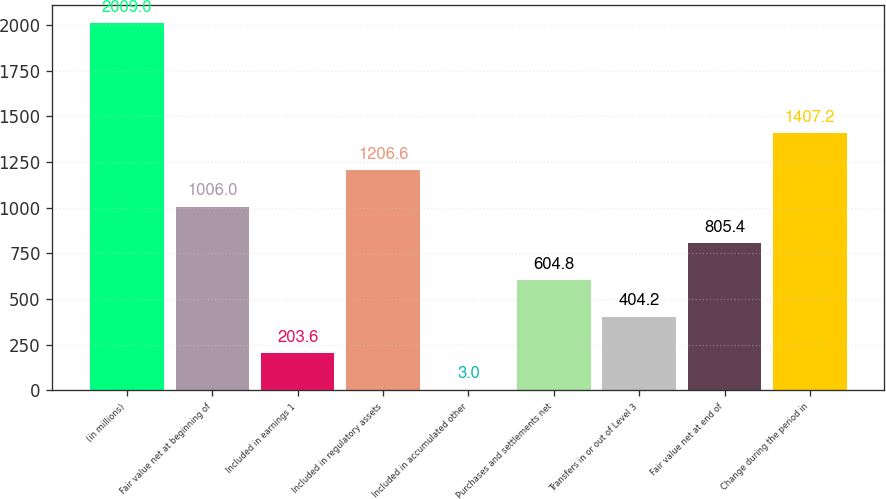Convert chart. <chart><loc_0><loc_0><loc_500><loc_500><bar_chart><fcel>(in millions)<fcel>Fair value net at beginning of<fcel>Included in earnings 1<fcel>Included in regulatory assets<fcel>Included in accumulated other<fcel>Purchases and settlements net<fcel>Transfers in or out of Level 3<fcel>Fair value net at end of<fcel>Change during the period in<nl><fcel>2009<fcel>1006<fcel>203.6<fcel>1206.6<fcel>3<fcel>604.8<fcel>404.2<fcel>805.4<fcel>1407.2<nl></chart> 